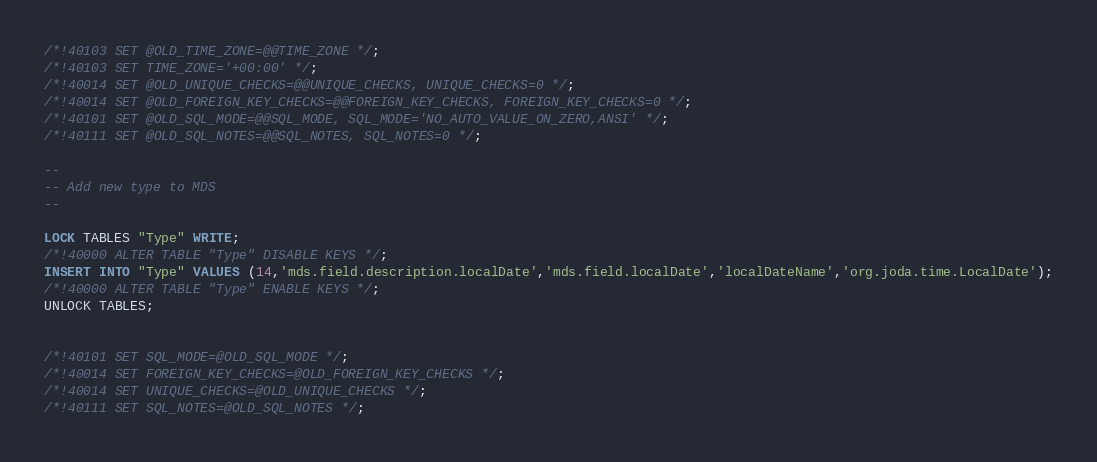<code> <loc_0><loc_0><loc_500><loc_500><_SQL_>/*!40103 SET @OLD_TIME_ZONE=@@TIME_ZONE */;
/*!40103 SET TIME_ZONE='+00:00' */;
/*!40014 SET @OLD_UNIQUE_CHECKS=@@UNIQUE_CHECKS, UNIQUE_CHECKS=0 */;
/*!40014 SET @OLD_FOREIGN_KEY_CHECKS=@@FOREIGN_KEY_CHECKS, FOREIGN_KEY_CHECKS=0 */;
/*!40101 SET @OLD_SQL_MODE=@@SQL_MODE, SQL_MODE='NO_AUTO_VALUE_ON_ZERO,ANSI' */;
/*!40111 SET @OLD_SQL_NOTES=@@SQL_NOTES, SQL_NOTES=0 */;

--
-- Add new type to MDS
--

LOCK TABLES "Type" WRITE;
/*!40000 ALTER TABLE "Type" DISABLE KEYS */;
INSERT INTO "Type" VALUES (14,'mds.field.description.localDate','mds.field.localDate','localDateName','org.joda.time.LocalDate');
/*!40000 ALTER TABLE "Type" ENABLE KEYS */;
UNLOCK TABLES;


/*!40101 SET SQL_MODE=@OLD_SQL_MODE */;
/*!40014 SET FOREIGN_KEY_CHECKS=@OLD_FOREIGN_KEY_CHECKS */;
/*!40014 SET UNIQUE_CHECKS=@OLD_UNIQUE_CHECKS */;
/*!40111 SET SQL_NOTES=@OLD_SQL_NOTES */;
</code> 